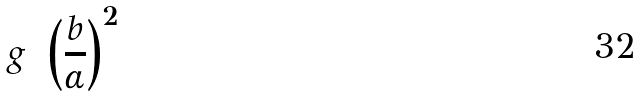<formula> <loc_0><loc_0><loc_500><loc_500>g = \left ( \frac { b } { \alpha } \right ) ^ { 2 }</formula> 